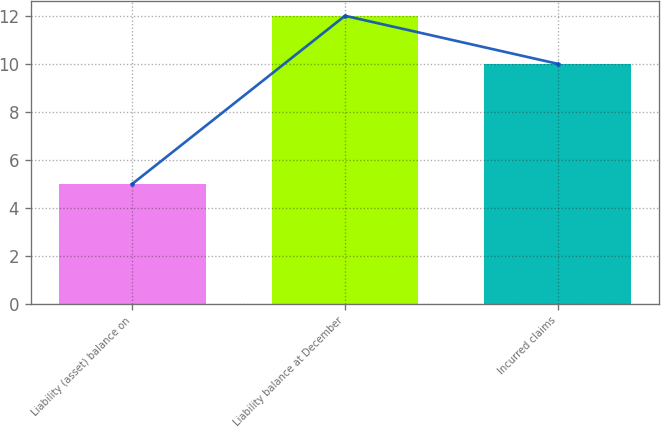<chart> <loc_0><loc_0><loc_500><loc_500><bar_chart><fcel>Liability (asset) balance on<fcel>Liability balance at December<fcel>Incurred claims<nl><fcel>5<fcel>12<fcel>10<nl></chart> 